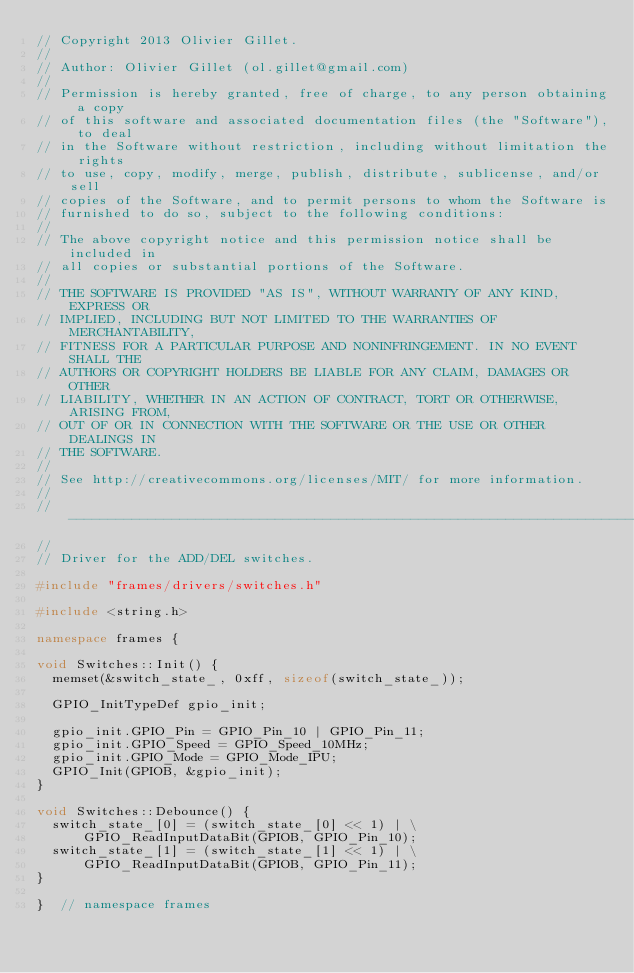<code> <loc_0><loc_0><loc_500><loc_500><_C++_>// Copyright 2013 Olivier Gillet.
//
// Author: Olivier Gillet (ol.gillet@gmail.com)
//
// Permission is hereby granted, free of charge, to any person obtaining a copy
// of this software and associated documentation files (the "Software"), to deal
// in the Software without restriction, including without limitation the rights
// to use, copy, modify, merge, publish, distribute, sublicense, and/or sell
// copies of the Software, and to permit persons to whom the Software is
// furnished to do so, subject to the following conditions:
// 
// The above copyright notice and this permission notice shall be included in
// all copies or substantial portions of the Software.
// 
// THE SOFTWARE IS PROVIDED "AS IS", WITHOUT WARRANTY OF ANY KIND, EXPRESS OR
// IMPLIED, INCLUDING BUT NOT LIMITED TO THE WARRANTIES OF MERCHANTABILITY,
// FITNESS FOR A PARTICULAR PURPOSE AND NONINFRINGEMENT. IN NO EVENT SHALL THE
// AUTHORS OR COPYRIGHT HOLDERS BE LIABLE FOR ANY CLAIM, DAMAGES OR OTHER
// LIABILITY, WHETHER IN AN ACTION OF CONTRACT, TORT OR OTHERWISE, ARISING FROM,
// OUT OF OR IN CONNECTION WITH THE SOFTWARE OR THE USE OR OTHER DEALINGS IN
// THE SOFTWARE.
// 
// See http://creativecommons.org/licenses/MIT/ for more information.
//
// -----------------------------------------------------------------------------
//
// Driver for the ADD/DEL switches.

#include "frames/drivers/switches.h"

#include <string.h>

namespace frames {

void Switches::Init() {
  memset(&switch_state_, 0xff, sizeof(switch_state_));
  
  GPIO_InitTypeDef gpio_init;

  gpio_init.GPIO_Pin = GPIO_Pin_10 | GPIO_Pin_11;
  gpio_init.GPIO_Speed = GPIO_Speed_10MHz;
  gpio_init.GPIO_Mode = GPIO_Mode_IPU;
  GPIO_Init(GPIOB, &gpio_init);
}

void Switches::Debounce() {
  switch_state_[0] = (switch_state_[0] << 1) | \
      GPIO_ReadInputDataBit(GPIOB, GPIO_Pin_10);
  switch_state_[1] = (switch_state_[1] << 1) | \
      GPIO_ReadInputDataBit(GPIOB, GPIO_Pin_11);
}

}  // namespace frames
</code> 